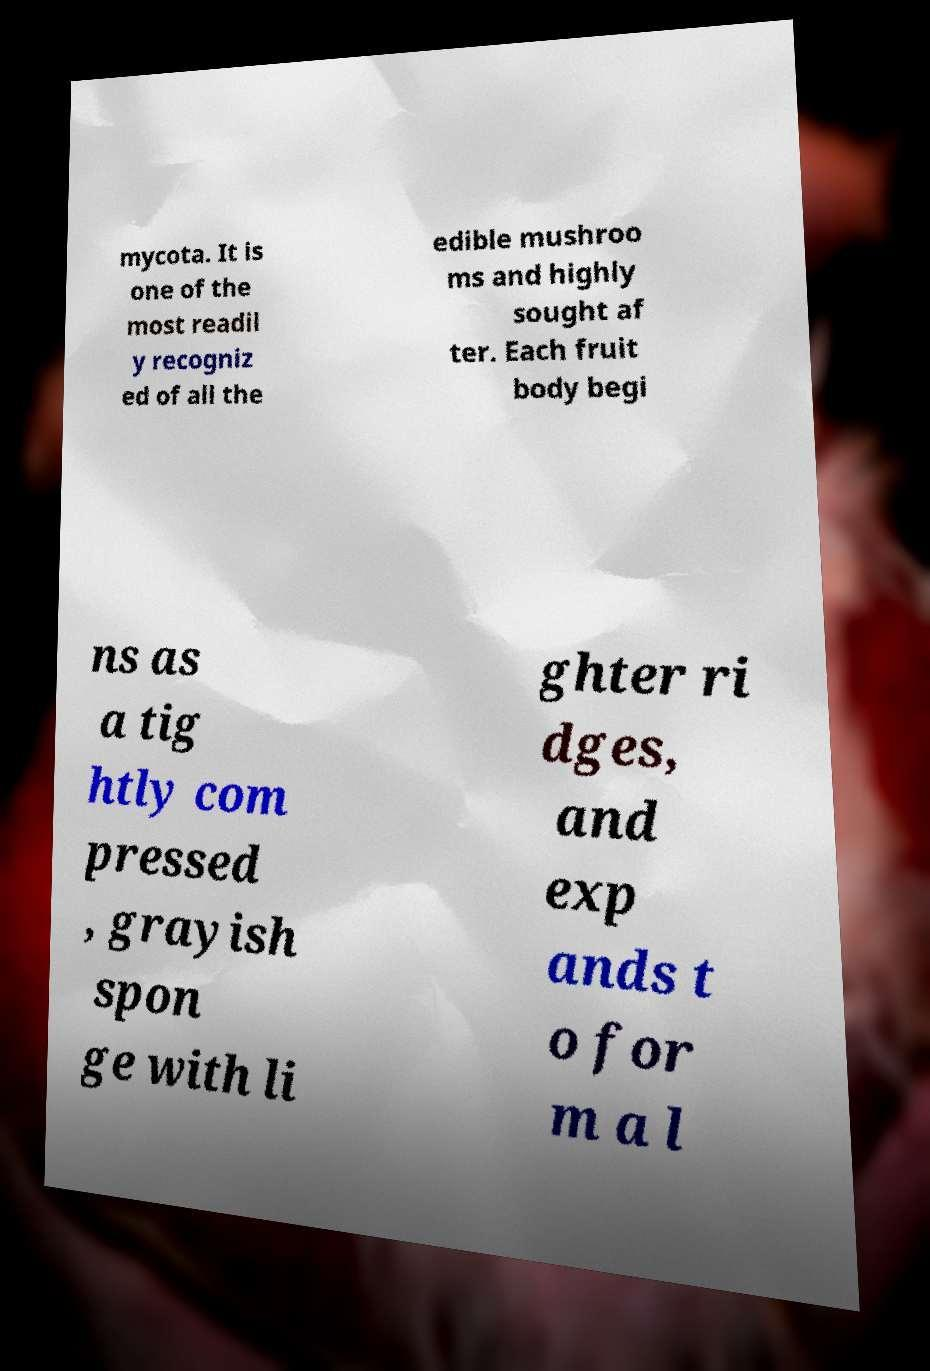Please read and relay the text visible in this image. What does it say? mycota. It is one of the most readil y recogniz ed of all the edible mushroo ms and highly sought af ter. Each fruit body begi ns as a tig htly com pressed , grayish spon ge with li ghter ri dges, and exp ands t o for m a l 